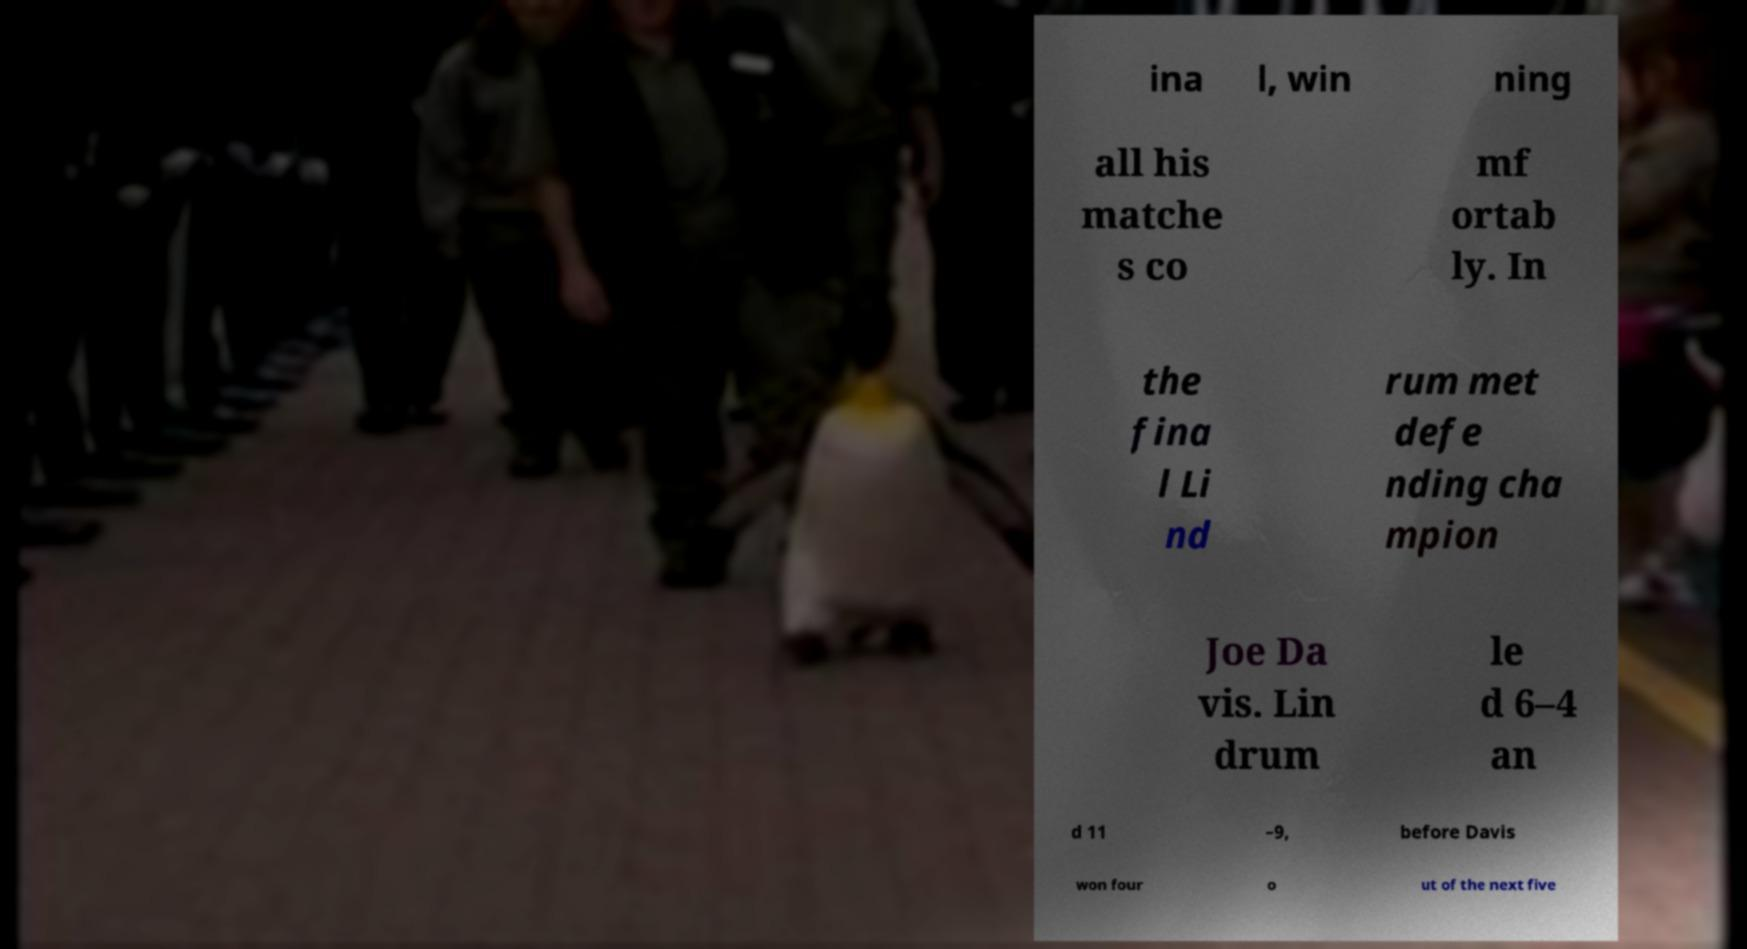Could you assist in decoding the text presented in this image and type it out clearly? ina l, win ning all his matche s co mf ortab ly. In the fina l Li nd rum met defe nding cha mpion Joe Da vis. Lin drum le d 6–4 an d 11 –9, before Davis won four o ut of the next five 